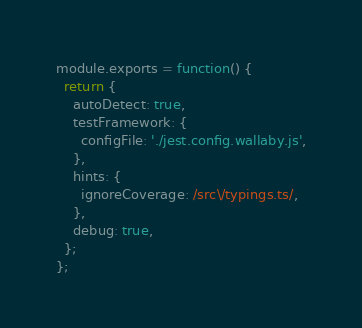Convert code to text. <code><loc_0><loc_0><loc_500><loc_500><_JavaScript_>module.exports = function() {
  return {
    autoDetect: true,
    testFramework: {
      configFile: './jest.config.wallaby.js',
    },
    hints: {
      ignoreCoverage: /src\/typings.ts/,
    },
    debug: true,
  };
};
</code> 